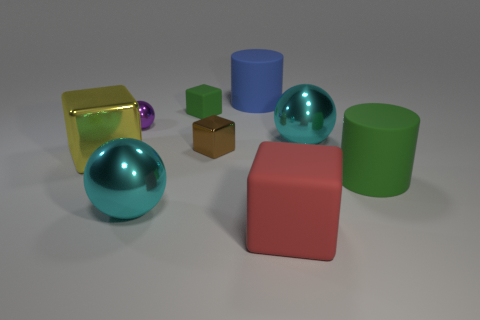What number of large cylinders have the same color as the small matte object?
Keep it short and to the point. 1. Is the number of big yellow cubes that are on the right side of the big yellow shiny cube the same as the number of tiny metallic spheres that are in front of the red rubber cube?
Offer a very short reply. Yes. Are there any other things that have the same material as the purple sphere?
Provide a succinct answer. Yes. There is a tiny shiny thing to the left of the small matte thing; what is its color?
Provide a succinct answer. Purple. Are there an equal number of rubber cubes that are behind the large red block and brown blocks?
Make the answer very short. Yes. How many other objects are there of the same shape as the brown shiny thing?
Offer a very short reply. 3. How many metal things are right of the purple ball?
Offer a very short reply. 3. There is a ball that is both right of the small purple object and left of the blue cylinder; how big is it?
Offer a very short reply. Large. Are there any big red metallic cubes?
Give a very brief answer. No. What number of other things are there of the same size as the yellow metallic thing?
Your response must be concise. 5. 